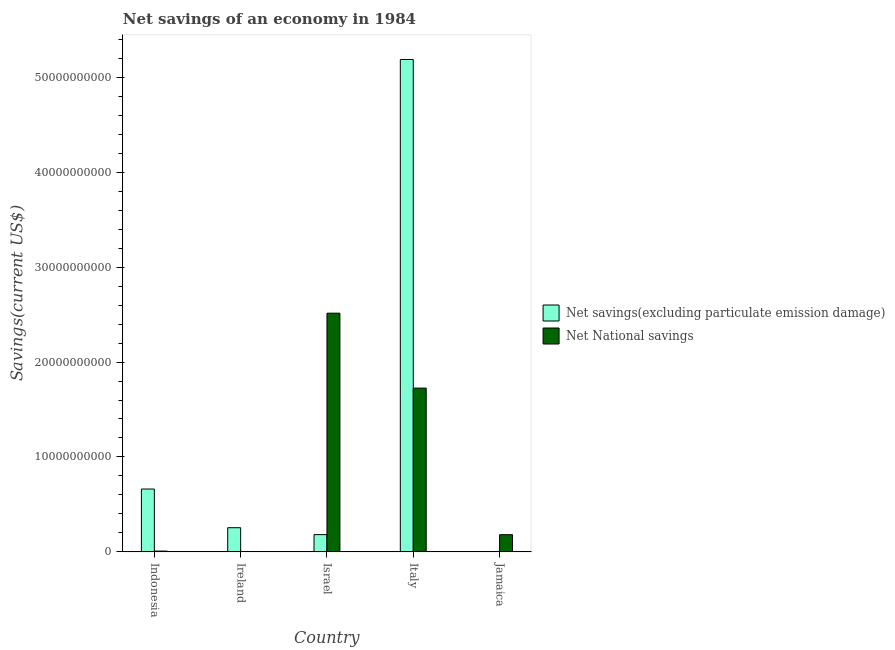Are the number of bars per tick equal to the number of legend labels?
Ensure brevity in your answer.  No. What is the label of the 5th group of bars from the left?
Offer a terse response. Jamaica. What is the net savings(excluding particulate emission damage) in Italy?
Offer a very short reply. 5.19e+1. Across all countries, what is the maximum net savings(excluding particulate emission damage)?
Offer a terse response. 5.19e+1. Across all countries, what is the minimum net national savings?
Provide a succinct answer. 3.84e+07. In which country was the net national savings maximum?
Make the answer very short. Israel. What is the total net savings(excluding particulate emission damage) in the graph?
Ensure brevity in your answer.  6.29e+1. What is the difference between the net national savings in Italy and that in Jamaica?
Your response must be concise. 1.54e+1. What is the difference between the net savings(excluding particulate emission damage) in Israel and the net national savings in Ireland?
Offer a very short reply. 1.78e+09. What is the average net savings(excluding particulate emission damage) per country?
Your answer should be compact. 1.26e+1. What is the difference between the net savings(excluding particulate emission damage) and net national savings in Indonesia?
Provide a short and direct response. 6.54e+09. In how many countries, is the net national savings greater than 2000000000 US$?
Provide a short and direct response. 2. What is the ratio of the net national savings in Indonesia to that in Jamaica?
Provide a succinct answer. 0.05. What is the difference between the highest and the second highest net national savings?
Ensure brevity in your answer.  7.90e+09. What is the difference between the highest and the lowest net national savings?
Offer a very short reply. 2.51e+1. How many bars are there?
Provide a succinct answer. 9. How many countries are there in the graph?
Provide a short and direct response. 5. Are the values on the major ticks of Y-axis written in scientific E-notation?
Your response must be concise. No. Does the graph contain any zero values?
Give a very brief answer. Yes. Does the graph contain grids?
Provide a succinct answer. No. How many legend labels are there?
Make the answer very short. 2. What is the title of the graph?
Offer a terse response. Net savings of an economy in 1984. What is the label or title of the X-axis?
Offer a very short reply. Country. What is the label or title of the Y-axis?
Provide a succinct answer. Savings(current US$). What is the Savings(current US$) of Net savings(excluding particulate emission damage) in Indonesia?
Your answer should be compact. 6.62e+09. What is the Savings(current US$) in Net National savings in Indonesia?
Your answer should be very brief. 8.27e+07. What is the Savings(current US$) of Net savings(excluding particulate emission damage) in Ireland?
Your response must be concise. 2.55e+09. What is the Savings(current US$) of Net National savings in Ireland?
Offer a terse response. 3.84e+07. What is the Savings(current US$) of Net savings(excluding particulate emission damage) in Israel?
Offer a terse response. 1.82e+09. What is the Savings(current US$) of Net National savings in Israel?
Make the answer very short. 2.51e+1. What is the Savings(current US$) of Net savings(excluding particulate emission damage) in Italy?
Your answer should be very brief. 5.19e+1. What is the Savings(current US$) of Net National savings in Italy?
Your response must be concise. 1.73e+1. What is the Savings(current US$) of Net National savings in Jamaica?
Give a very brief answer. 1.81e+09. Across all countries, what is the maximum Savings(current US$) of Net savings(excluding particulate emission damage)?
Your answer should be compact. 5.19e+1. Across all countries, what is the maximum Savings(current US$) of Net National savings?
Your answer should be very brief. 2.51e+1. Across all countries, what is the minimum Savings(current US$) in Net National savings?
Give a very brief answer. 3.84e+07. What is the total Savings(current US$) in Net savings(excluding particulate emission damage) in the graph?
Offer a very short reply. 6.29e+1. What is the total Savings(current US$) of Net National savings in the graph?
Offer a very short reply. 4.43e+1. What is the difference between the Savings(current US$) of Net savings(excluding particulate emission damage) in Indonesia and that in Ireland?
Your answer should be compact. 4.07e+09. What is the difference between the Savings(current US$) in Net National savings in Indonesia and that in Ireland?
Provide a short and direct response. 4.43e+07. What is the difference between the Savings(current US$) in Net savings(excluding particulate emission damage) in Indonesia and that in Israel?
Offer a terse response. 4.80e+09. What is the difference between the Savings(current US$) in Net National savings in Indonesia and that in Israel?
Ensure brevity in your answer.  -2.51e+1. What is the difference between the Savings(current US$) in Net savings(excluding particulate emission damage) in Indonesia and that in Italy?
Keep it short and to the point. -4.53e+1. What is the difference between the Savings(current US$) of Net National savings in Indonesia and that in Italy?
Provide a succinct answer. -1.72e+1. What is the difference between the Savings(current US$) of Net National savings in Indonesia and that in Jamaica?
Your answer should be very brief. -1.73e+09. What is the difference between the Savings(current US$) in Net savings(excluding particulate emission damage) in Ireland and that in Israel?
Your response must be concise. 7.28e+08. What is the difference between the Savings(current US$) in Net National savings in Ireland and that in Israel?
Your answer should be compact. -2.51e+1. What is the difference between the Savings(current US$) in Net savings(excluding particulate emission damage) in Ireland and that in Italy?
Provide a succinct answer. -4.93e+1. What is the difference between the Savings(current US$) of Net National savings in Ireland and that in Italy?
Offer a terse response. -1.72e+1. What is the difference between the Savings(current US$) of Net National savings in Ireland and that in Jamaica?
Provide a short and direct response. -1.77e+09. What is the difference between the Savings(current US$) of Net savings(excluding particulate emission damage) in Israel and that in Italy?
Give a very brief answer. -5.01e+1. What is the difference between the Savings(current US$) in Net National savings in Israel and that in Italy?
Your response must be concise. 7.90e+09. What is the difference between the Savings(current US$) in Net National savings in Israel and that in Jamaica?
Provide a short and direct response. 2.33e+1. What is the difference between the Savings(current US$) of Net National savings in Italy and that in Jamaica?
Keep it short and to the point. 1.54e+1. What is the difference between the Savings(current US$) of Net savings(excluding particulate emission damage) in Indonesia and the Savings(current US$) of Net National savings in Ireland?
Offer a very short reply. 6.58e+09. What is the difference between the Savings(current US$) in Net savings(excluding particulate emission damage) in Indonesia and the Savings(current US$) in Net National savings in Israel?
Give a very brief answer. -1.85e+1. What is the difference between the Savings(current US$) of Net savings(excluding particulate emission damage) in Indonesia and the Savings(current US$) of Net National savings in Italy?
Your answer should be compact. -1.06e+1. What is the difference between the Savings(current US$) of Net savings(excluding particulate emission damage) in Indonesia and the Savings(current US$) of Net National savings in Jamaica?
Make the answer very short. 4.81e+09. What is the difference between the Savings(current US$) of Net savings(excluding particulate emission damage) in Ireland and the Savings(current US$) of Net National savings in Israel?
Give a very brief answer. -2.26e+1. What is the difference between the Savings(current US$) in Net savings(excluding particulate emission damage) in Ireland and the Savings(current US$) in Net National savings in Italy?
Your answer should be very brief. -1.47e+1. What is the difference between the Savings(current US$) in Net savings(excluding particulate emission damage) in Ireland and the Savings(current US$) in Net National savings in Jamaica?
Your answer should be very brief. 7.36e+08. What is the difference between the Savings(current US$) in Net savings(excluding particulate emission damage) in Israel and the Savings(current US$) in Net National savings in Italy?
Ensure brevity in your answer.  -1.54e+1. What is the difference between the Savings(current US$) in Net savings(excluding particulate emission damage) in Israel and the Savings(current US$) in Net National savings in Jamaica?
Provide a succinct answer. 8.09e+06. What is the difference between the Savings(current US$) in Net savings(excluding particulate emission damage) in Italy and the Savings(current US$) in Net National savings in Jamaica?
Your answer should be compact. 5.01e+1. What is the average Savings(current US$) in Net savings(excluding particulate emission damage) per country?
Make the answer very short. 1.26e+1. What is the average Savings(current US$) in Net National savings per country?
Offer a very short reply. 8.87e+09. What is the difference between the Savings(current US$) in Net savings(excluding particulate emission damage) and Savings(current US$) in Net National savings in Indonesia?
Provide a succinct answer. 6.54e+09. What is the difference between the Savings(current US$) in Net savings(excluding particulate emission damage) and Savings(current US$) in Net National savings in Ireland?
Offer a very short reply. 2.51e+09. What is the difference between the Savings(current US$) in Net savings(excluding particulate emission damage) and Savings(current US$) in Net National savings in Israel?
Ensure brevity in your answer.  -2.33e+1. What is the difference between the Savings(current US$) of Net savings(excluding particulate emission damage) and Savings(current US$) of Net National savings in Italy?
Offer a terse response. 3.46e+1. What is the ratio of the Savings(current US$) in Net savings(excluding particulate emission damage) in Indonesia to that in Ireland?
Make the answer very short. 2.6. What is the ratio of the Savings(current US$) of Net National savings in Indonesia to that in Ireland?
Make the answer very short. 2.15. What is the ratio of the Savings(current US$) of Net savings(excluding particulate emission damage) in Indonesia to that in Israel?
Provide a short and direct response. 3.64. What is the ratio of the Savings(current US$) in Net National savings in Indonesia to that in Israel?
Give a very brief answer. 0. What is the ratio of the Savings(current US$) in Net savings(excluding particulate emission damage) in Indonesia to that in Italy?
Make the answer very short. 0.13. What is the ratio of the Savings(current US$) of Net National savings in Indonesia to that in Italy?
Your answer should be very brief. 0. What is the ratio of the Savings(current US$) of Net National savings in Indonesia to that in Jamaica?
Provide a short and direct response. 0.05. What is the ratio of the Savings(current US$) of Net savings(excluding particulate emission damage) in Ireland to that in Israel?
Give a very brief answer. 1.4. What is the ratio of the Savings(current US$) in Net National savings in Ireland to that in Israel?
Make the answer very short. 0. What is the ratio of the Savings(current US$) of Net savings(excluding particulate emission damage) in Ireland to that in Italy?
Give a very brief answer. 0.05. What is the ratio of the Savings(current US$) of Net National savings in Ireland to that in Italy?
Give a very brief answer. 0. What is the ratio of the Savings(current US$) of Net National savings in Ireland to that in Jamaica?
Your response must be concise. 0.02. What is the ratio of the Savings(current US$) of Net savings(excluding particulate emission damage) in Israel to that in Italy?
Give a very brief answer. 0.04. What is the ratio of the Savings(current US$) of Net National savings in Israel to that in Italy?
Provide a succinct answer. 1.46. What is the ratio of the Savings(current US$) in Net National savings in Israel to that in Jamaica?
Make the answer very short. 13.89. What is the ratio of the Savings(current US$) of Net National savings in Italy to that in Jamaica?
Offer a terse response. 9.53. What is the difference between the highest and the second highest Savings(current US$) in Net savings(excluding particulate emission damage)?
Your answer should be very brief. 4.53e+1. What is the difference between the highest and the second highest Savings(current US$) in Net National savings?
Your answer should be compact. 7.90e+09. What is the difference between the highest and the lowest Savings(current US$) in Net savings(excluding particulate emission damage)?
Provide a short and direct response. 5.19e+1. What is the difference between the highest and the lowest Savings(current US$) of Net National savings?
Your answer should be compact. 2.51e+1. 